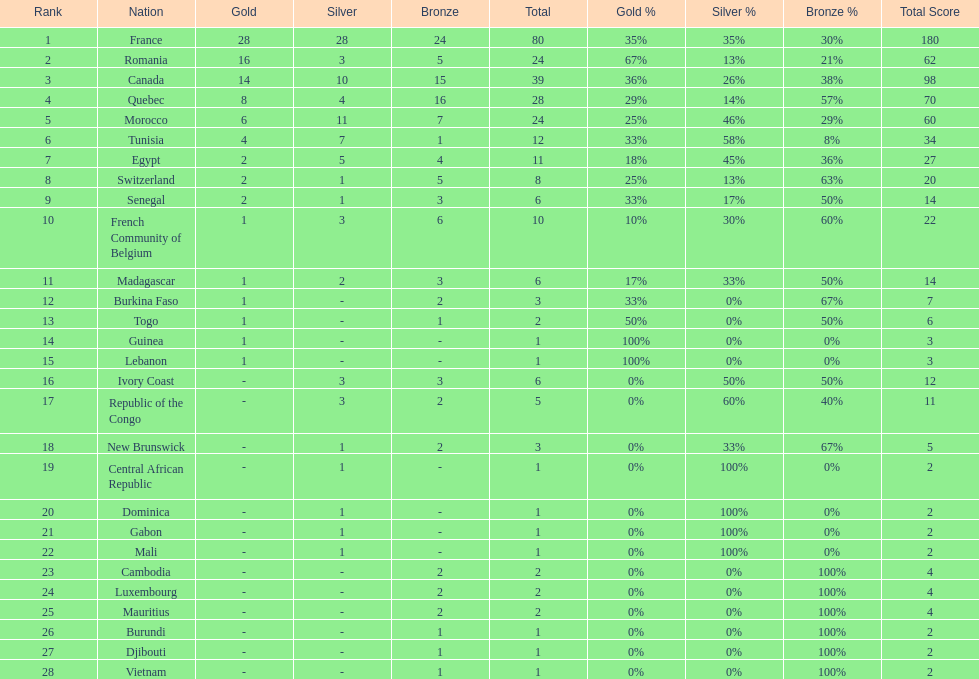What is the difference between france's and egypt's silver medals? 23. 